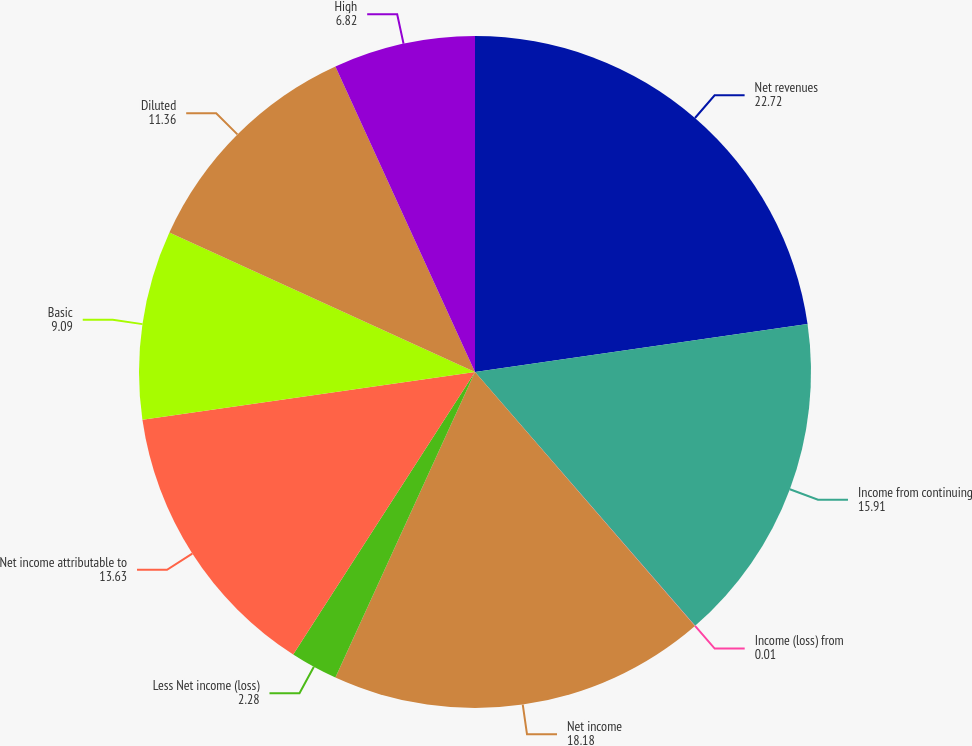Convert chart. <chart><loc_0><loc_0><loc_500><loc_500><pie_chart><fcel>Net revenues<fcel>Income from continuing<fcel>Income (loss) from<fcel>Net income<fcel>Less Net income (loss)<fcel>Net income attributable to<fcel>Basic<fcel>Diluted<fcel>High<nl><fcel>22.72%<fcel>15.91%<fcel>0.01%<fcel>18.18%<fcel>2.28%<fcel>13.63%<fcel>9.09%<fcel>11.36%<fcel>6.82%<nl></chart> 